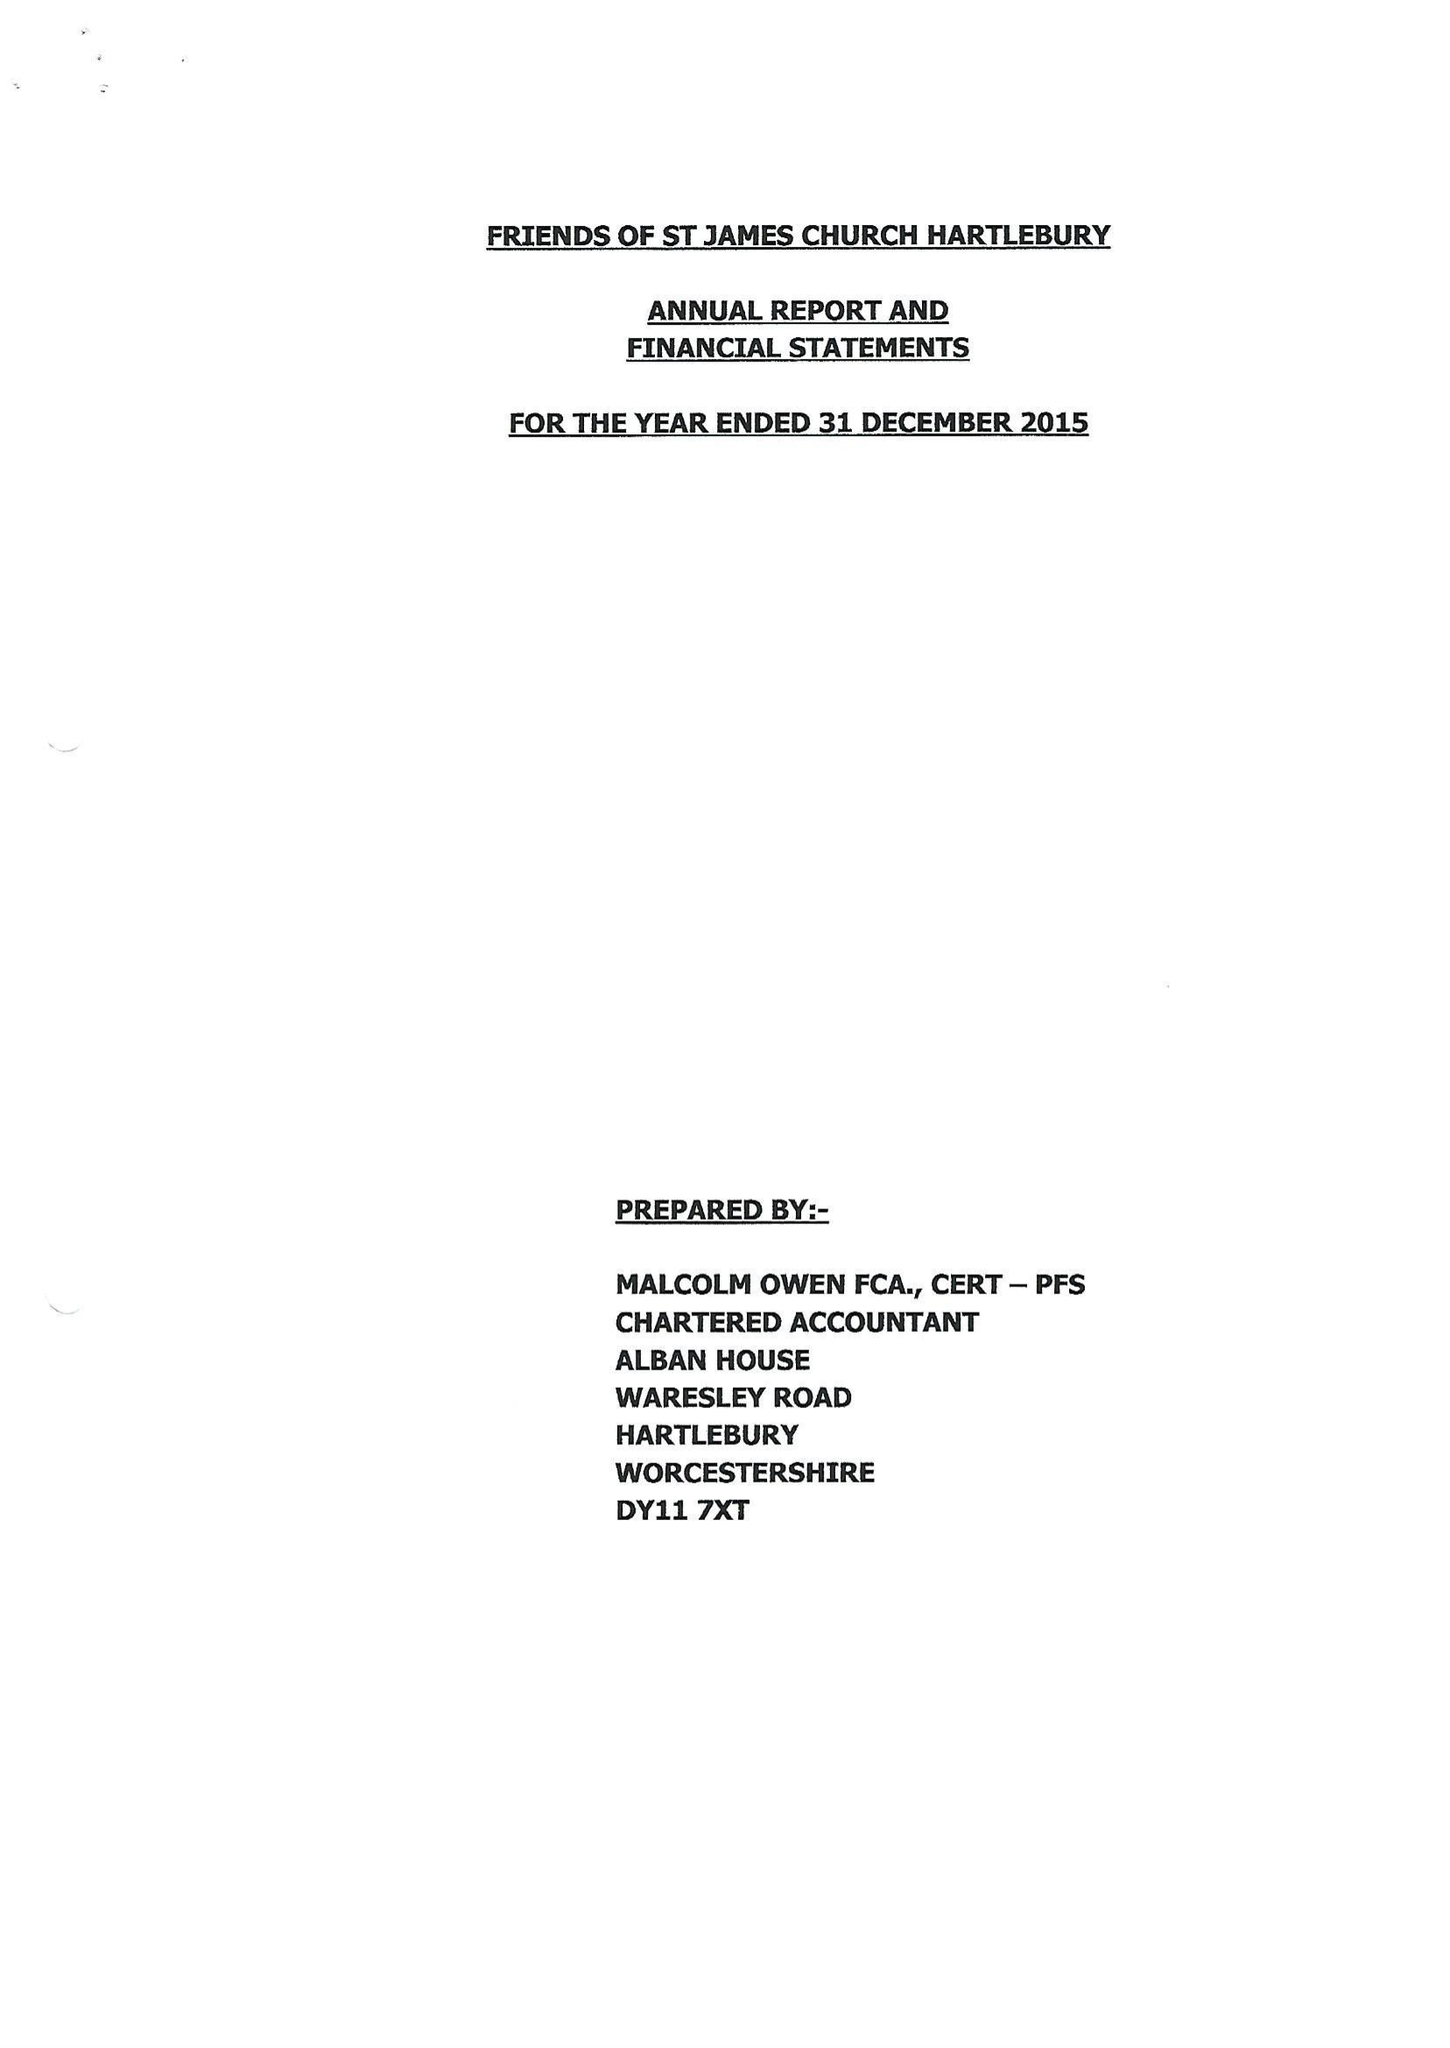What is the value for the address__street_line?
Answer the question using a single word or phrase. WARESLEY ROAD 